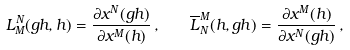<formula> <loc_0><loc_0><loc_500><loc_500>L _ { M } ^ { N } ( g h , h ) = \frac { \partial x ^ { N } ( g h ) } { \partial x ^ { M } ( h ) } \, , \quad \overline { L } _ { N } ^ { M } ( h , g h ) = \frac { \partial x ^ { M } ( h ) } { \partial x ^ { N } ( g h ) } \, ,</formula> 